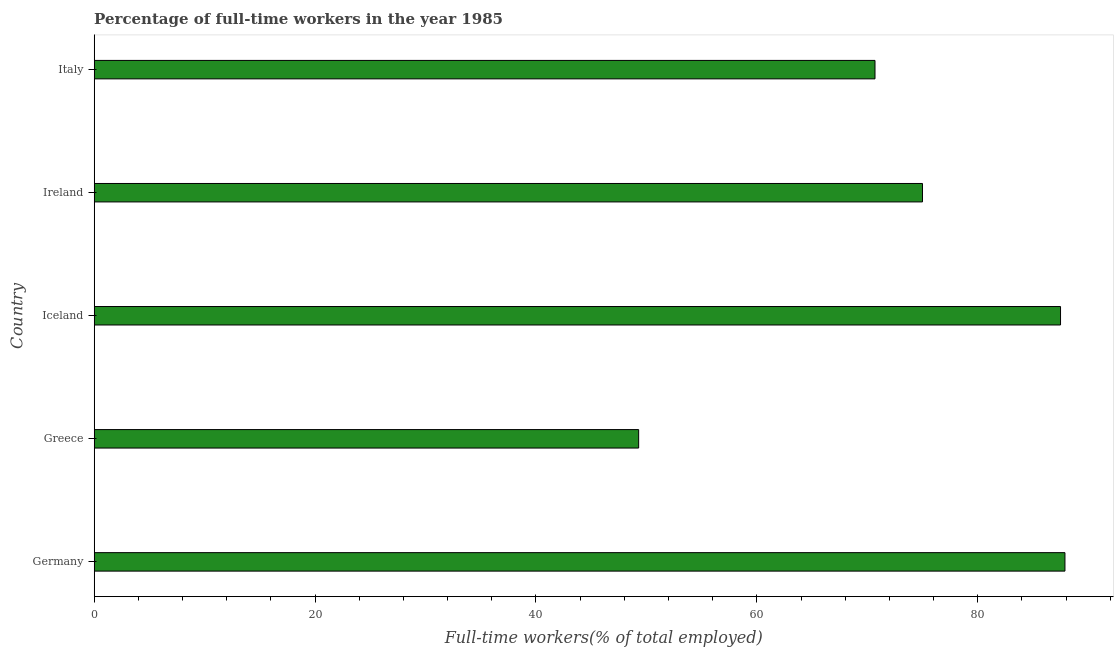What is the title of the graph?
Your response must be concise. Percentage of full-time workers in the year 1985. What is the label or title of the X-axis?
Offer a terse response. Full-time workers(% of total employed). What is the percentage of full-time workers in Italy?
Ensure brevity in your answer.  70.7. Across all countries, what is the maximum percentage of full-time workers?
Offer a very short reply. 87.9. Across all countries, what is the minimum percentage of full-time workers?
Ensure brevity in your answer.  49.3. In which country was the percentage of full-time workers minimum?
Provide a short and direct response. Greece. What is the sum of the percentage of full-time workers?
Provide a short and direct response. 370.4. What is the difference between the percentage of full-time workers in Germany and Italy?
Offer a very short reply. 17.2. What is the average percentage of full-time workers per country?
Your answer should be compact. 74.08. In how many countries, is the percentage of full-time workers greater than 80 %?
Your answer should be compact. 2. What is the ratio of the percentage of full-time workers in Iceland to that in Ireland?
Offer a very short reply. 1.17. Is the percentage of full-time workers in Greece less than that in Italy?
Provide a succinct answer. Yes. What is the difference between the highest and the lowest percentage of full-time workers?
Keep it short and to the point. 38.6. Are all the bars in the graph horizontal?
Offer a very short reply. Yes. How many countries are there in the graph?
Provide a short and direct response. 5. What is the Full-time workers(% of total employed) in Germany?
Your response must be concise. 87.9. What is the Full-time workers(% of total employed) in Greece?
Offer a terse response. 49.3. What is the Full-time workers(% of total employed) in Iceland?
Make the answer very short. 87.5. What is the Full-time workers(% of total employed) in Italy?
Provide a succinct answer. 70.7. What is the difference between the Full-time workers(% of total employed) in Germany and Greece?
Offer a very short reply. 38.6. What is the difference between the Full-time workers(% of total employed) in Germany and Ireland?
Ensure brevity in your answer.  12.9. What is the difference between the Full-time workers(% of total employed) in Germany and Italy?
Ensure brevity in your answer.  17.2. What is the difference between the Full-time workers(% of total employed) in Greece and Iceland?
Give a very brief answer. -38.2. What is the difference between the Full-time workers(% of total employed) in Greece and Ireland?
Ensure brevity in your answer.  -25.7. What is the difference between the Full-time workers(% of total employed) in Greece and Italy?
Provide a succinct answer. -21.4. What is the difference between the Full-time workers(% of total employed) in Ireland and Italy?
Offer a very short reply. 4.3. What is the ratio of the Full-time workers(% of total employed) in Germany to that in Greece?
Give a very brief answer. 1.78. What is the ratio of the Full-time workers(% of total employed) in Germany to that in Ireland?
Ensure brevity in your answer.  1.17. What is the ratio of the Full-time workers(% of total employed) in Germany to that in Italy?
Your answer should be very brief. 1.24. What is the ratio of the Full-time workers(% of total employed) in Greece to that in Iceland?
Ensure brevity in your answer.  0.56. What is the ratio of the Full-time workers(% of total employed) in Greece to that in Ireland?
Give a very brief answer. 0.66. What is the ratio of the Full-time workers(% of total employed) in Greece to that in Italy?
Offer a very short reply. 0.7. What is the ratio of the Full-time workers(% of total employed) in Iceland to that in Ireland?
Give a very brief answer. 1.17. What is the ratio of the Full-time workers(% of total employed) in Iceland to that in Italy?
Make the answer very short. 1.24. What is the ratio of the Full-time workers(% of total employed) in Ireland to that in Italy?
Ensure brevity in your answer.  1.06. 